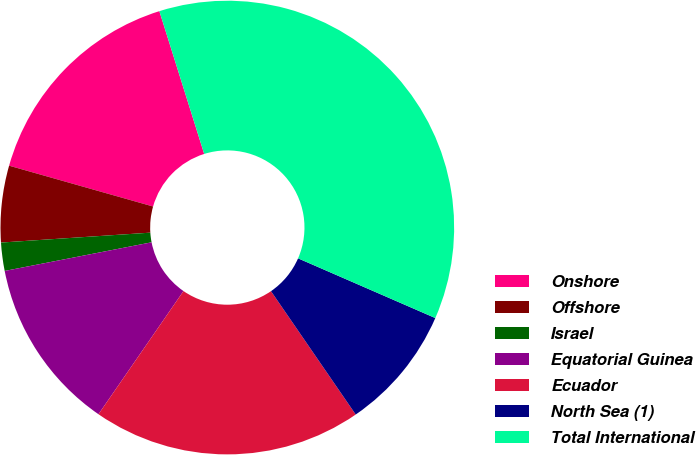Convert chart to OTSL. <chart><loc_0><loc_0><loc_500><loc_500><pie_chart><fcel>Onshore<fcel>Offshore<fcel>Israel<fcel>Equatorial Guinea<fcel>Ecuador<fcel>North Sea (1)<fcel>Total International<nl><fcel>15.76%<fcel>5.45%<fcel>2.01%<fcel>12.32%<fcel>19.19%<fcel>8.89%<fcel>36.37%<nl></chart> 